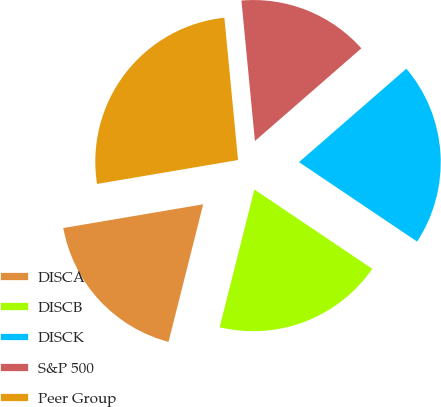<chart> <loc_0><loc_0><loc_500><loc_500><pie_chart><fcel>DISCA<fcel>DISCB<fcel>DISCK<fcel>S&P 500<fcel>Peer Group<nl><fcel>18.4%<fcel>19.5%<fcel>20.83%<fcel>15.12%<fcel>26.15%<nl></chart> 